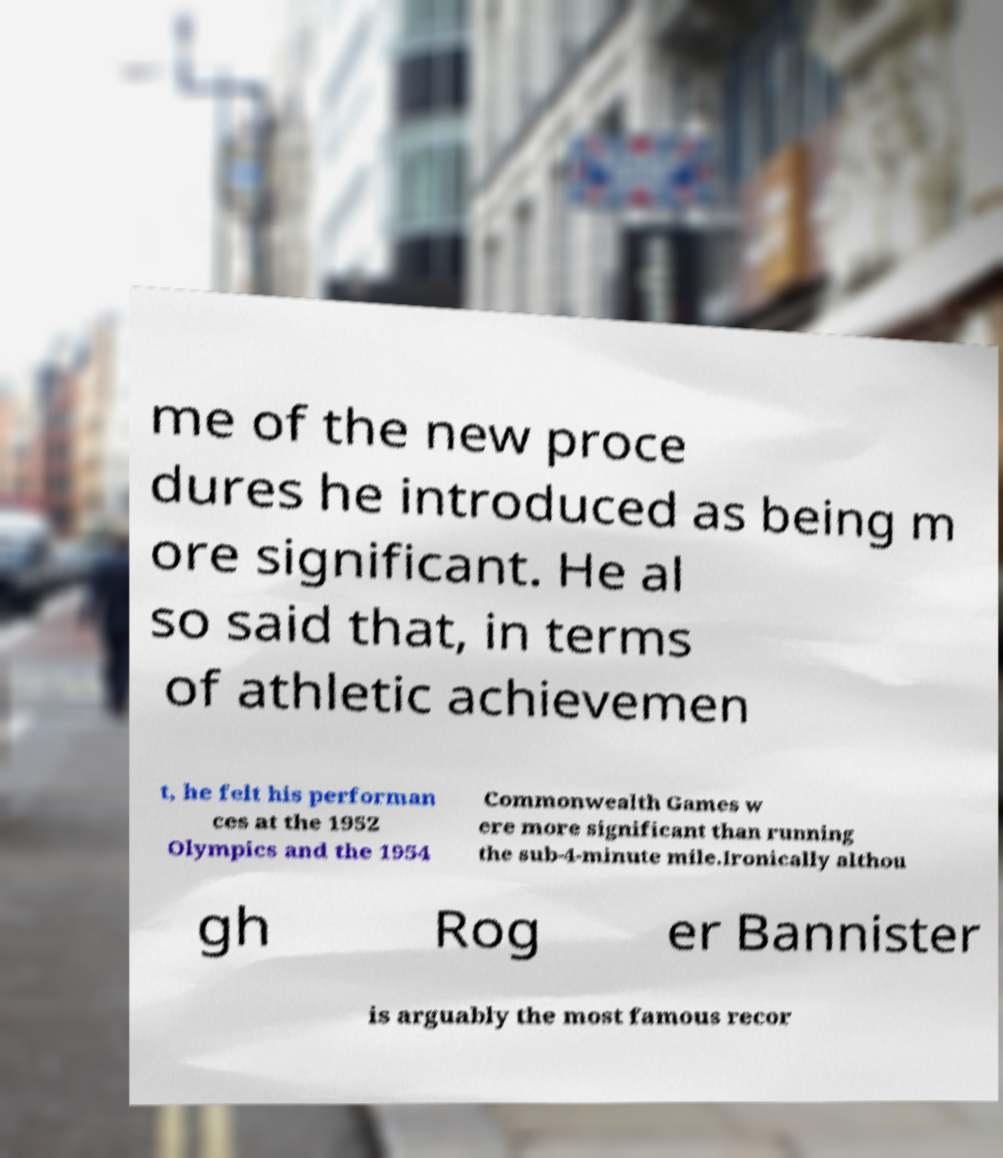Please identify and transcribe the text found in this image. me of the new proce dures he introduced as being m ore significant. He al so said that, in terms of athletic achievemen t, he felt his performan ces at the 1952 Olympics and the 1954 Commonwealth Games w ere more significant than running the sub-4-minute mile.Ironically althou gh Rog er Bannister is arguably the most famous recor 